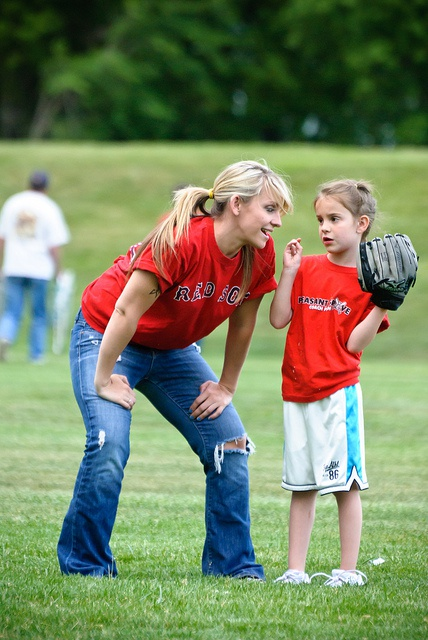Describe the objects in this image and their specific colors. I can see people in black, navy, maroon, and blue tones, people in black, lightgray, red, lightpink, and darkgray tones, people in black, white, darkgray, and teal tones, and baseball glove in black, darkgray, gray, and lightgray tones in this image. 